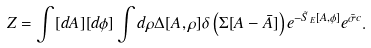Convert formula to latex. <formula><loc_0><loc_0><loc_500><loc_500>Z = \int [ d A ] [ d \phi ] \int d \rho \Delta [ A , \rho ] \delta \left ( \Sigma [ A - \bar { A } ] \right ) e ^ { - \tilde { S } _ { E } [ A , \phi ] } e ^ { \bar { \sigma } c } .</formula> 